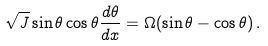<formula> <loc_0><loc_0><loc_500><loc_500>\sqrt { J } \sin { \theta } \cos { \theta } \frac { d \theta } { d x } = \Omega ( \sin \theta - \cos \theta ) \, .</formula> 